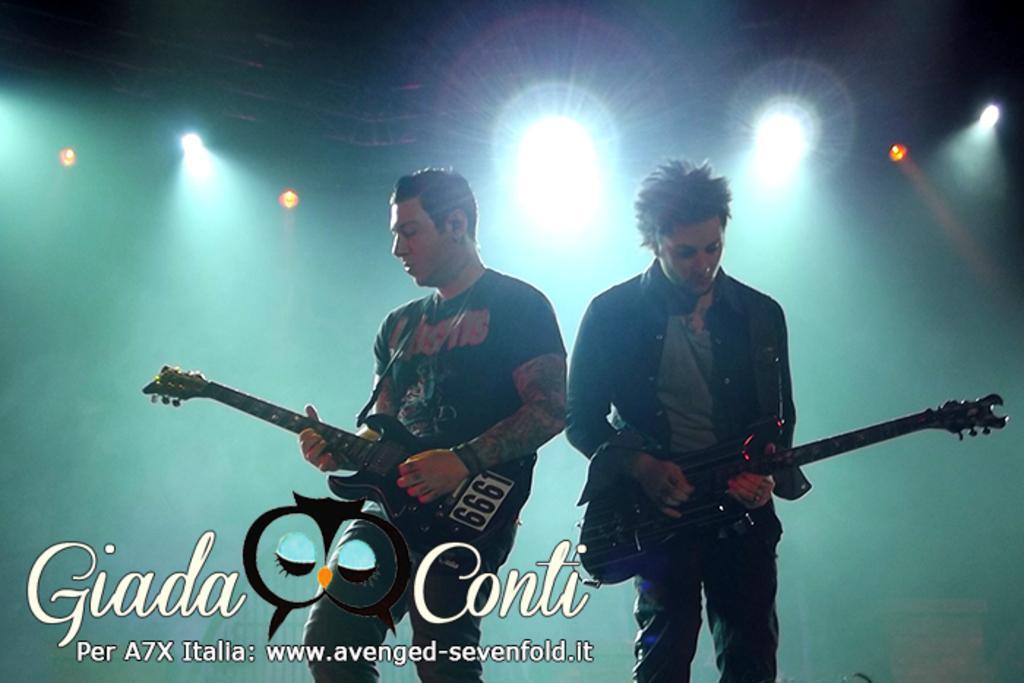Can you describe this image briefly? In this image we can see two men Standing and playing guitars, in the background we can see some of the lights here. 